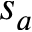Convert formula to latex. <formula><loc_0><loc_0><loc_500><loc_500>s _ { a }</formula> 